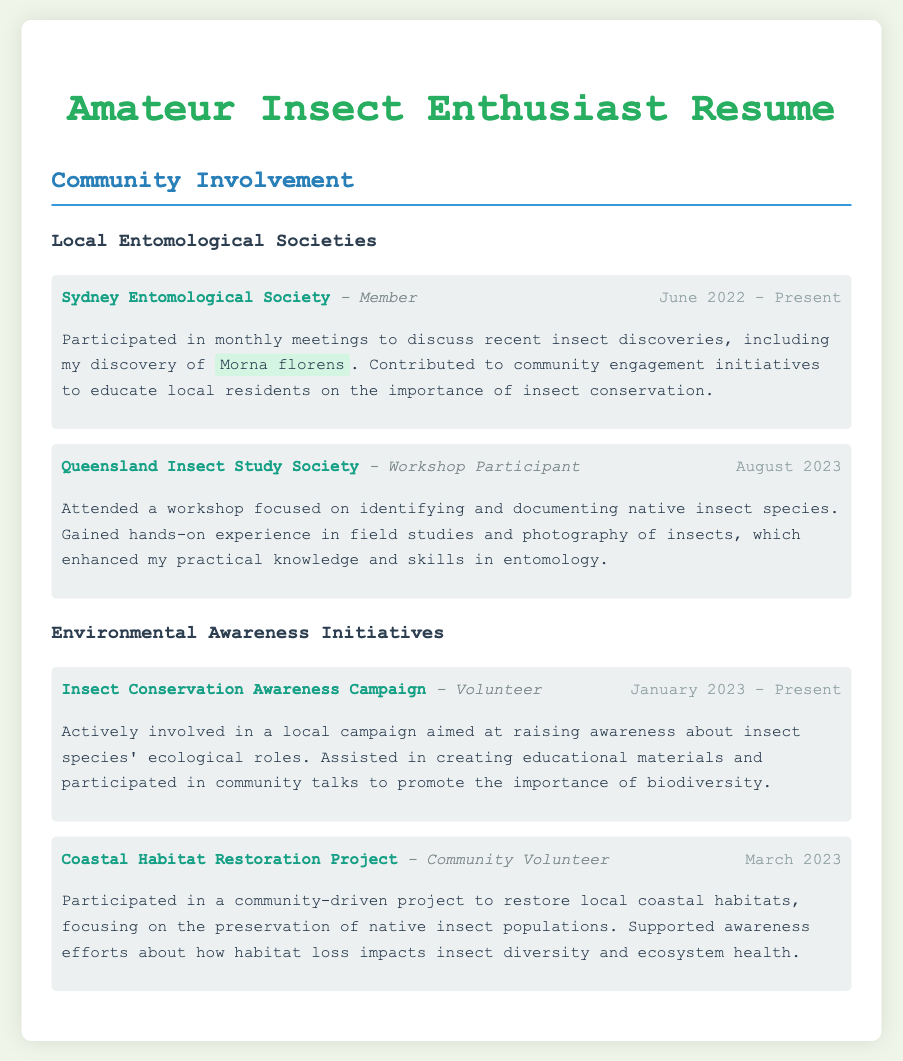what is the name of the society the individual is a member of? The name of the society mentioned in the document is the Sydney Entomological Society, where the individual is a member.
Answer: Sydney Entomological Society what role does the individual have in the Insect Conservation Awareness Campaign? The role in the Insect Conservation Awareness Campaign is specified as a volunteer.
Answer: Volunteer when did the individual participate in the Queensland Insect Study Society workshop? The document states the individual attended the workshop in August 2023.
Answer: August 2023 what species did the individual discover and mention during meetings? The species discovered and mentioned during meetings is Morna florens.
Answer: Morna florens in which environmental initiative did the individual support efforts about habitat loss? The individual supported awareness efforts about habitat loss in the Coastal Habitat Restoration Project.
Answer: Coastal Habitat Restoration Project how long has the individual been a member of the Sydney Entomological Society? The individual has been a member since June 2022, making their duration of membership from June 2022 to the present.
Answer: June 2022 - Present what type of experience did the individual gain from the workshop? The workshop provided hands-on experience in identifying and documenting native insect species.
Answer: Hands-on experience what is one of the key focuses of the community talks the individual participated in? The community talks aimed to promote the importance of biodiversity regarding insect species' ecological roles.
Answer: Importance of biodiversity 